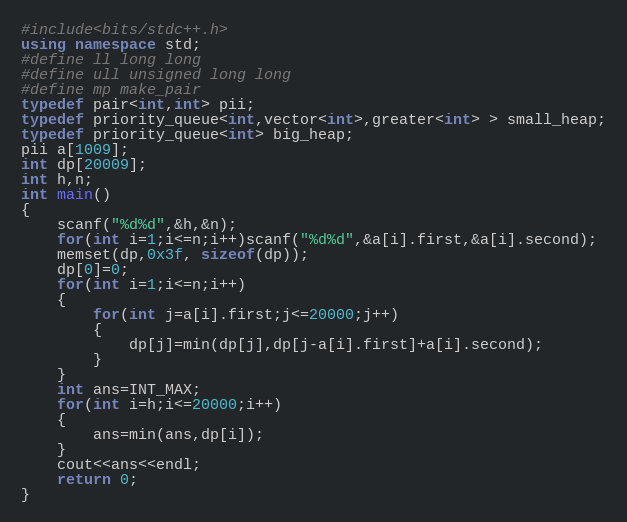Convert code to text. <code><loc_0><loc_0><loc_500><loc_500><_C++_>#include<bits/stdc++.h>
using namespace std;
#define ll long long
#define ull unsigned long long
#define mp make_pair
typedef pair<int,int> pii;
typedef priority_queue<int,vector<int>,greater<int> > small_heap;
typedef priority_queue<int> big_heap;
pii a[1009];
int dp[20009];
int h,n;
int main()
{
    scanf("%d%d",&h,&n);
    for(int i=1;i<=n;i++)scanf("%d%d",&a[i].first,&a[i].second);
    memset(dp,0x3f, sizeof(dp));
    dp[0]=0;
    for(int i=1;i<=n;i++)
    {
        for(int j=a[i].first;j<=20000;j++)
        {
            dp[j]=min(dp[j],dp[j-a[i].first]+a[i].second);
        }
    }
    int ans=INT_MAX;
    for(int i=h;i<=20000;i++)
    {
        ans=min(ans,dp[i]);
    }
    cout<<ans<<endl;
    return 0;
}</code> 